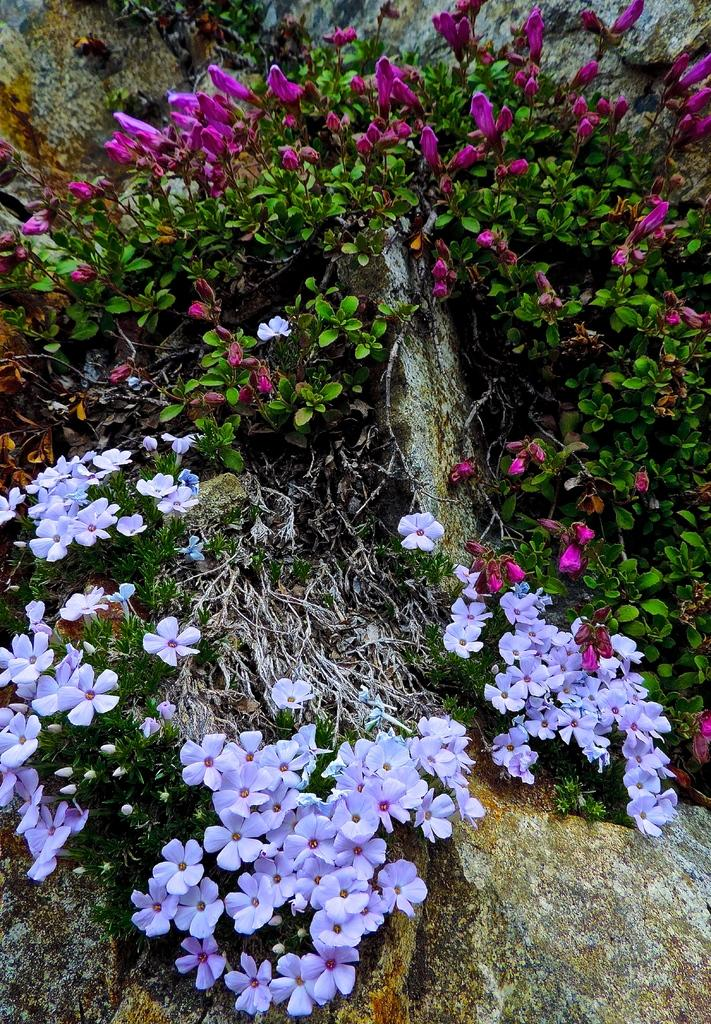What is growing on the rocks in the image? There are plants on the rocks in the image. What features do the plants have? The plants have leaves and flowers. What colors are the flowers? The flowers are in pink and white colors. How many quarters can be seen on the plants in the image? There are no quarters present in the image; it features plants with leaves and flowers. 